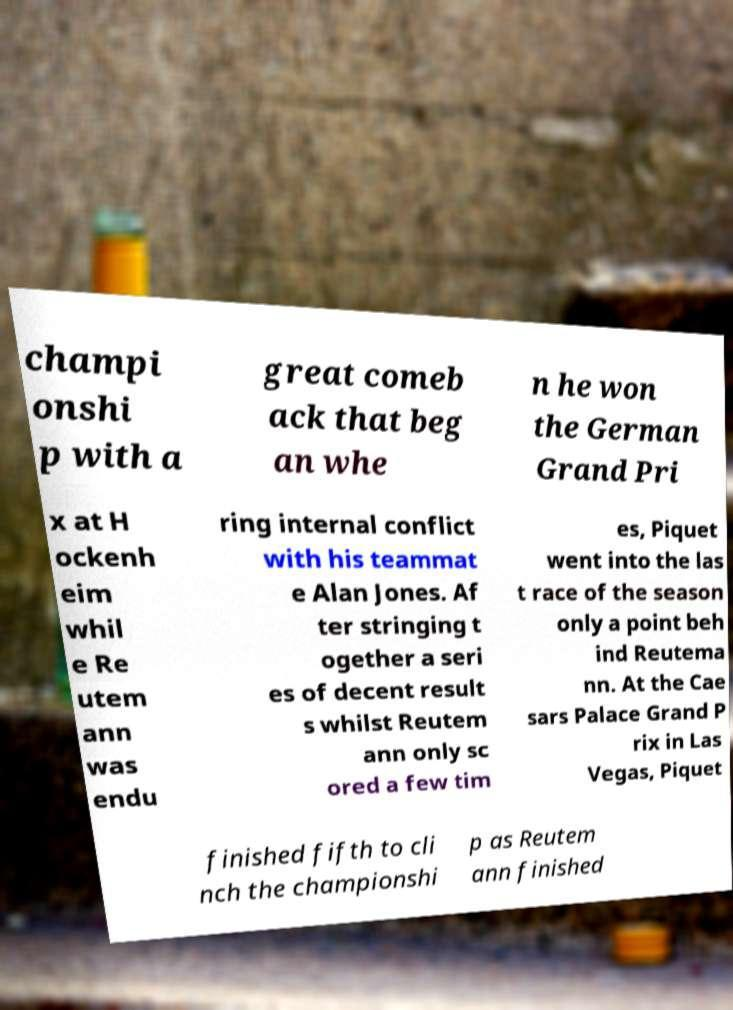I need the written content from this picture converted into text. Can you do that? champi onshi p with a great comeb ack that beg an whe n he won the German Grand Pri x at H ockenh eim whil e Re utem ann was endu ring internal conflict with his teammat e Alan Jones. Af ter stringing t ogether a seri es of decent result s whilst Reutem ann only sc ored a few tim es, Piquet went into the las t race of the season only a point beh ind Reutema nn. At the Cae sars Palace Grand P rix in Las Vegas, Piquet finished fifth to cli nch the championshi p as Reutem ann finished 